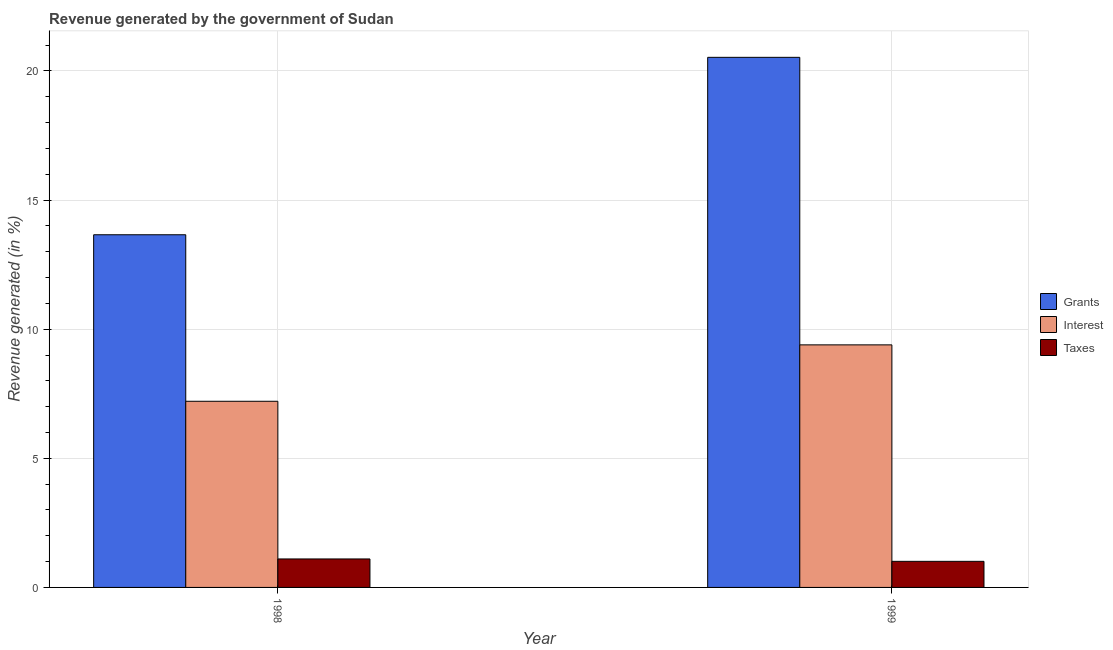How many different coloured bars are there?
Provide a succinct answer. 3. Are the number of bars per tick equal to the number of legend labels?
Your answer should be very brief. Yes. How many bars are there on the 1st tick from the left?
Keep it short and to the point. 3. What is the label of the 1st group of bars from the left?
Keep it short and to the point. 1998. What is the percentage of revenue generated by taxes in 1998?
Give a very brief answer. 1.1. Across all years, what is the maximum percentage of revenue generated by taxes?
Keep it short and to the point. 1.1. Across all years, what is the minimum percentage of revenue generated by grants?
Your answer should be compact. 13.66. What is the total percentage of revenue generated by interest in the graph?
Ensure brevity in your answer.  16.6. What is the difference between the percentage of revenue generated by interest in 1998 and that in 1999?
Provide a short and direct response. -2.18. What is the difference between the percentage of revenue generated by interest in 1999 and the percentage of revenue generated by taxes in 1998?
Your answer should be compact. 2.18. What is the average percentage of revenue generated by interest per year?
Your answer should be compact. 8.3. In how many years, is the percentage of revenue generated by interest greater than 6 %?
Give a very brief answer. 2. What is the ratio of the percentage of revenue generated by taxes in 1998 to that in 1999?
Offer a very short reply. 1.09. In how many years, is the percentage of revenue generated by grants greater than the average percentage of revenue generated by grants taken over all years?
Your answer should be compact. 1. What does the 1st bar from the left in 1998 represents?
Your answer should be very brief. Grants. What does the 2nd bar from the right in 1999 represents?
Your answer should be very brief. Interest. Where does the legend appear in the graph?
Offer a very short reply. Center right. How many legend labels are there?
Give a very brief answer. 3. How are the legend labels stacked?
Ensure brevity in your answer.  Vertical. What is the title of the graph?
Make the answer very short. Revenue generated by the government of Sudan. What is the label or title of the Y-axis?
Keep it short and to the point. Revenue generated (in %). What is the Revenue generated (in %) of Grants in 1998?
Offer a very short reply. 13.66. What is the Revenue generated (in %) in Interest in 1998?
Keep it short and to the point. 7.21. What is the Revenue generated (in %) of Taxes in 1998?
Offer a terse response. 1.1. What is the Revenue generated (in %) of Grants in 1999?
Your response must be concise. 20.53. What is the Revenue generated (in %) in Interest in 1999?
Ensure brevity in your answer.  9.39. What is the Revenue generated (in %) in Taxes in 1999?
Your answer should be very brief. 1.01. Across all years, what is the maximum Revenue generated (in %) in Grants?
Give a very brief answer. 20.53. Across all years, what is the maximum Revenue generated (in %) in Interest?
Offer a terse response. 9.39. Across all years, what is the maximum Revenue generated (in %) in Taxes?
Ensure brevity in your answer.  1.1. Across all years, what is the minimum Revenue generated (in %) in Grants?
Offer a terse response. 13.66. Across all years, what is the minimum Revenue generated (in %) in Interest?
Your response must be concise. 7.21. Across all years, what is the minimum Revenue generated (in %) in Taxes?
Your answer should be very brief. 1.01. What is the total Revenue generated (in %) of Grants in the graph?
Provide a succinct answer. 34.19. What is the total Revenue generated (in %) of Interest in the graph?
Give a very brief answer. 16.6. What is the total Revenue generated (in %) in Taxes in the graph?
Ensure brevity in your answer.  2.11. What is the difference between the Revenue generated (in %) of Grants in 1998 and that in 1999?
Provide a short and direct response. -6.87. What is the difference between the Revenue generated (in %) in Interest in 1998 and that in 1999?
Offer a very short reply. -2.18. What is the difference between the Revenue generated (in %) of Taxes in 1998 and that in 1999?
Offer a very short reply. 0.09. What is the difference between the Revenue generated (in %) in Grants in 1998 and the Revenue generated (in %) in Interest in 1999?
Provide a short and direct response. 4.26. What is the difference between the Revenue generated (in %) in Grants in 1998 and the Revenue generated (in %) in Taxes in 1999?
Ensure brevity in your answer.  12.65. What is the difference between the Revenue generated (in %) in Interest in 1998 and the Revenue generated (in %) in Taxes in 1999?
Your response must be concise. 6.2. What is the average Revenue generated (in %) of Grants per year?
Your answer should be very brief. 17.09. What is the average Revenue generated (in %) in Interest per year?
Ensure brevity in your answer.  8.3. What is the average Revenue generated (in %) in Taxes per year?
Ensure brevity in your answer.  1.06. In the year 1998, what is the difference between the Revenue generated (in %) of Grants and Revenue generated (in %) of Interest?
Give a very brief answer. 6.45. In the year 1998, what is the difference between the Revenue generated (in %) in Grants and Revenue generated (in %) in Taxes?
Make the answer very short. 12.55. In the year 1998, what is the difference between the Revenue generated (in %) in Interest and Revenue generated (in %) in Taxes?
Offer a very short reply. 6.11. In the year 1999, what is the difference between the Revenue generated (in %) in Grants and Revenue generated (in %) in Interest?
Give a very brief answer. 11.14. In the year 1999, what is the difference between the Revenue generated (in %) in Grants and Revenue generated (in %) in Taxes?
Offer a terse response. 19.52. In the year 1999, what is the difference between the Revenue generated (in %) of Interest and Revenue generated (in %) of Taxes?
Offer a very short reply. 8.38. What is the ratio of the Revenue generated (in %) in Grants in 1998 to that in 1999?
Your response must be concise. 0.67. What is the ratio of the Revenue generated (in %) of Interest in 1998 to that in 1999?
Your answer should be compact. 0.77. What is the ratio of the Revenue generated (in %) in Taxes in 1998 to that in 1999?
Make the answer very short. 1.09. What is the difference between the highest and the second highest Revenue generated (in %) of Grants?
Your answer should be very brief. 6.87. What is the difference between the highest and the second highest Revenue generated (in %) in Interest?
Provide a short and direct response. 2.18. What is the difference between the highest and the second highest Revenue generated (in %) of Taxes?
Keep it short and to the point. 0.09. What is the difference between the highest and the lowest Revenue generated (in %) of Grants?
Your answer should be very brief. 6.87. What is the difference between the highest and the lowest Revenue generated (in %) in Interest?
Your answer should be very brief. 2.18. What is the difference between the highest and the lowest Revenue generated (in %) in Taxes?
Ensure brevity in your answer.  0.09. 